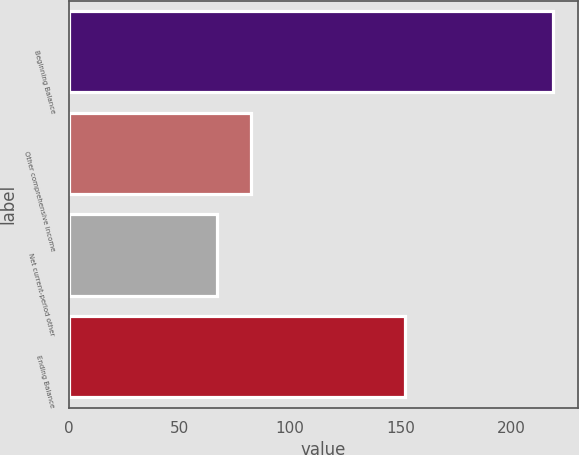Convert chart to OTSL. <chart><loc_0><loc_0><loc_500><loc_500><bar_chart><fcel>Beginning Balance<fcel>Other comprehensive income<fcel>Net current-period other<fcel>Ending Balance<nl><fcel>219<fcel>82.2<fcel>67<fcel>152<nl></chart> 